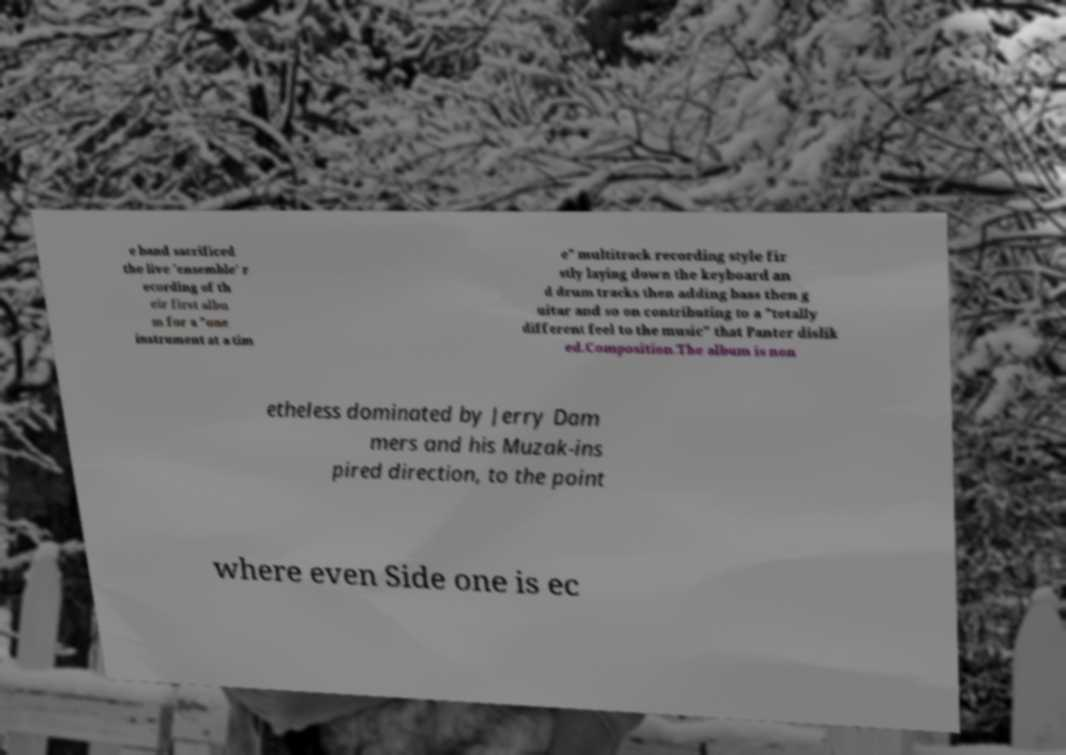Could you extract and type out the text from this image? e band sacrificed the live 'ensemble' r ecording of th eir first albu m for a "one instrument at a tim e" multitrack recording style fir stly laying down the keyboard an d drum tracks then adding bass then g uitar and so on contributing to a "totally different feel to the music" that Panter dislik ed.Composition.The album is non etheless dominated by Jerry Dam mers and his Muzak-ins pired direction, to the point where even Side one is ec 